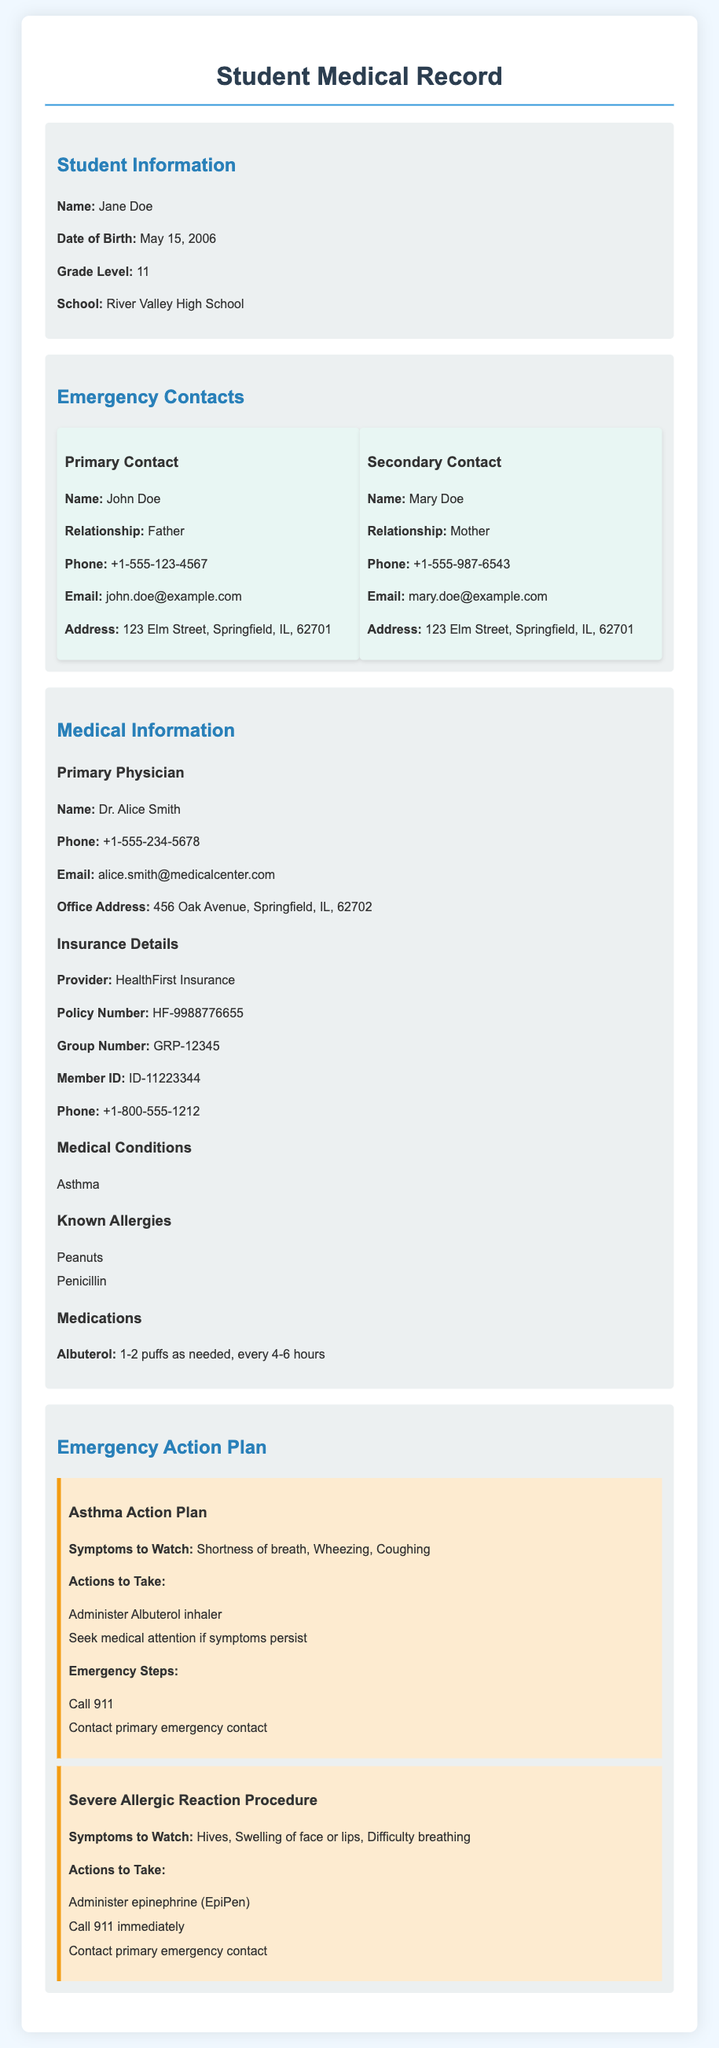What is the name of the student? The name of the student is found under the "Student Information" section.
Answer: Jane Doe Who is the primary emergency contact? The primary emergency contact is detailed in the "Emergency Contacts" section.
Answer: John Doe What is the phone number of the primary physician? The phone number of the primary physician is specified in the "Medical Information" section.
Answer: +1-555-234-5678 What medical condition does the student have? The specific medical condition(s) are listed in the "Medical Conditions" section.
Answer: Asthma What steps should be taken for a severe allergic reaction? The actions for a severe allergic reaction are outlined in the "Severe Allergic Reaction Procedure" under the "Emergency Action Plan".
Answer: Administer epinephrine, Call 911 How old is the student? The age of the student can be calculated using the date of birth and the current year given in the document.
Answer: 17 years What is the address of the primary emergency contact? The address is provided in the "Emergency Contacts" section for the primary contact.
Answer: 123 Elm Street, Springfield, IL, 62701 What symptoms should be watched for asthma? This information is provided in the "Asthma Action Plan" section of the document.
Answer: Shortness of breath, Wheezing, Coughing Which insurance provider does the student have? This information is indicated in the "Insurance Details" section.
Answer: HealthFirst Insurance 